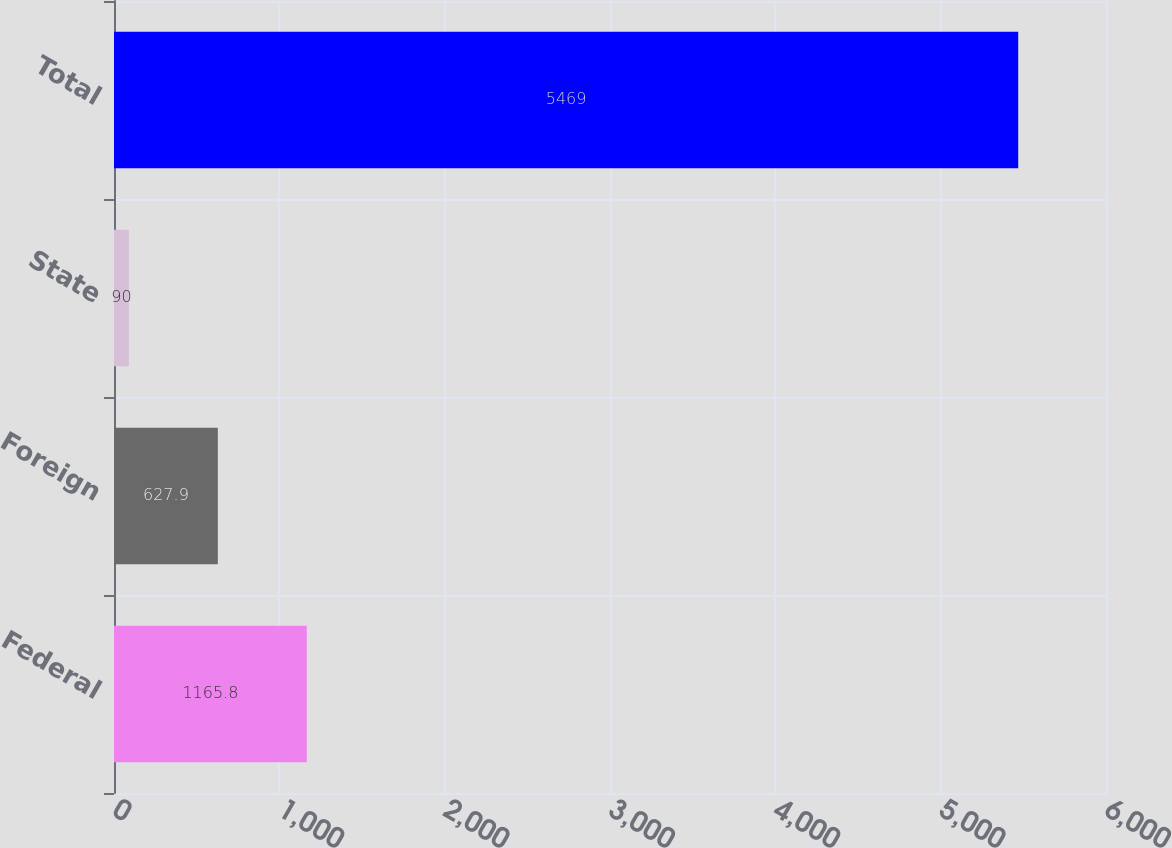<chart> <loc_0><loc_0><loc_500><loc_500><bar_chart><fcel>Federal<fcel>Foreign<fcel>State<fcel>Total<nl><fcel>1165.8<fcel>627.9<fcel>90<fcel>5469<nl></chart> 